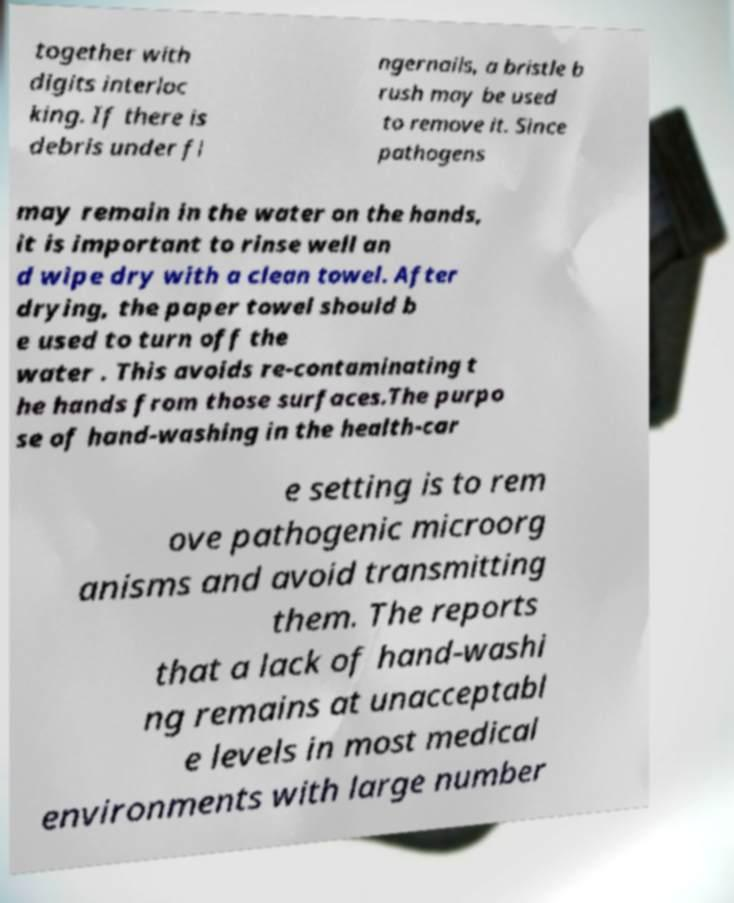Could you assist in decoding the text presented in this image and type it out clearly? together with digits interloc king. If there is debris under fi ngernails, a bristle b rush may be used to remove it. Since pathogens may remain in the water on the hands, it is important to rinse well an d wipe dry with a clean towel. After drying, the paper towel should b e used to turn off the water . This avoids re-contaminating t he hands from those surfaces.The purpo se of hand-washing in the health-car e setting is to rem ove pathogenic microorg anisms and avoid transmitting them. The reports that a lack of hand-washi ng remains at unacceptabl e levels in most medical environments with large number 